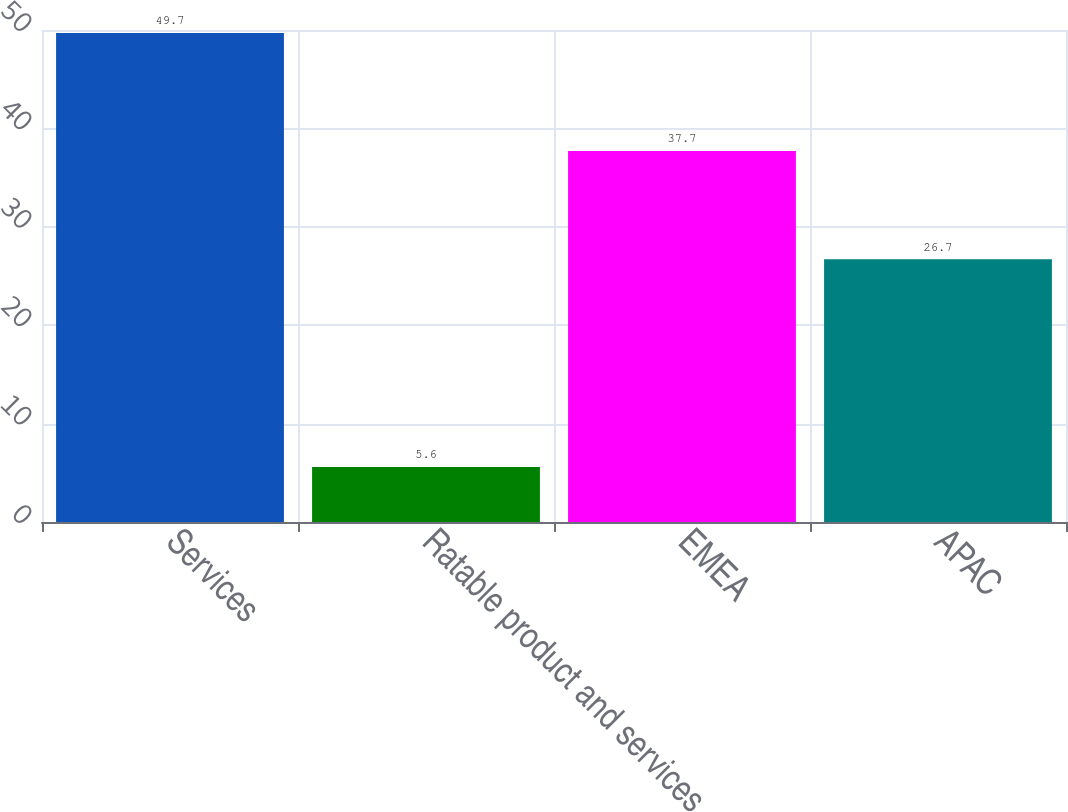<chart> <loc_0><loc_0><loc_500><loc_500><bar_chart><fcel>Services<fcel>Ratable product and services<fcel>EMEA<fcel>APAC<nl><fcel>49.7<fcel>5.6<fcel>37.7<fcel>26.7<nl></chart> 